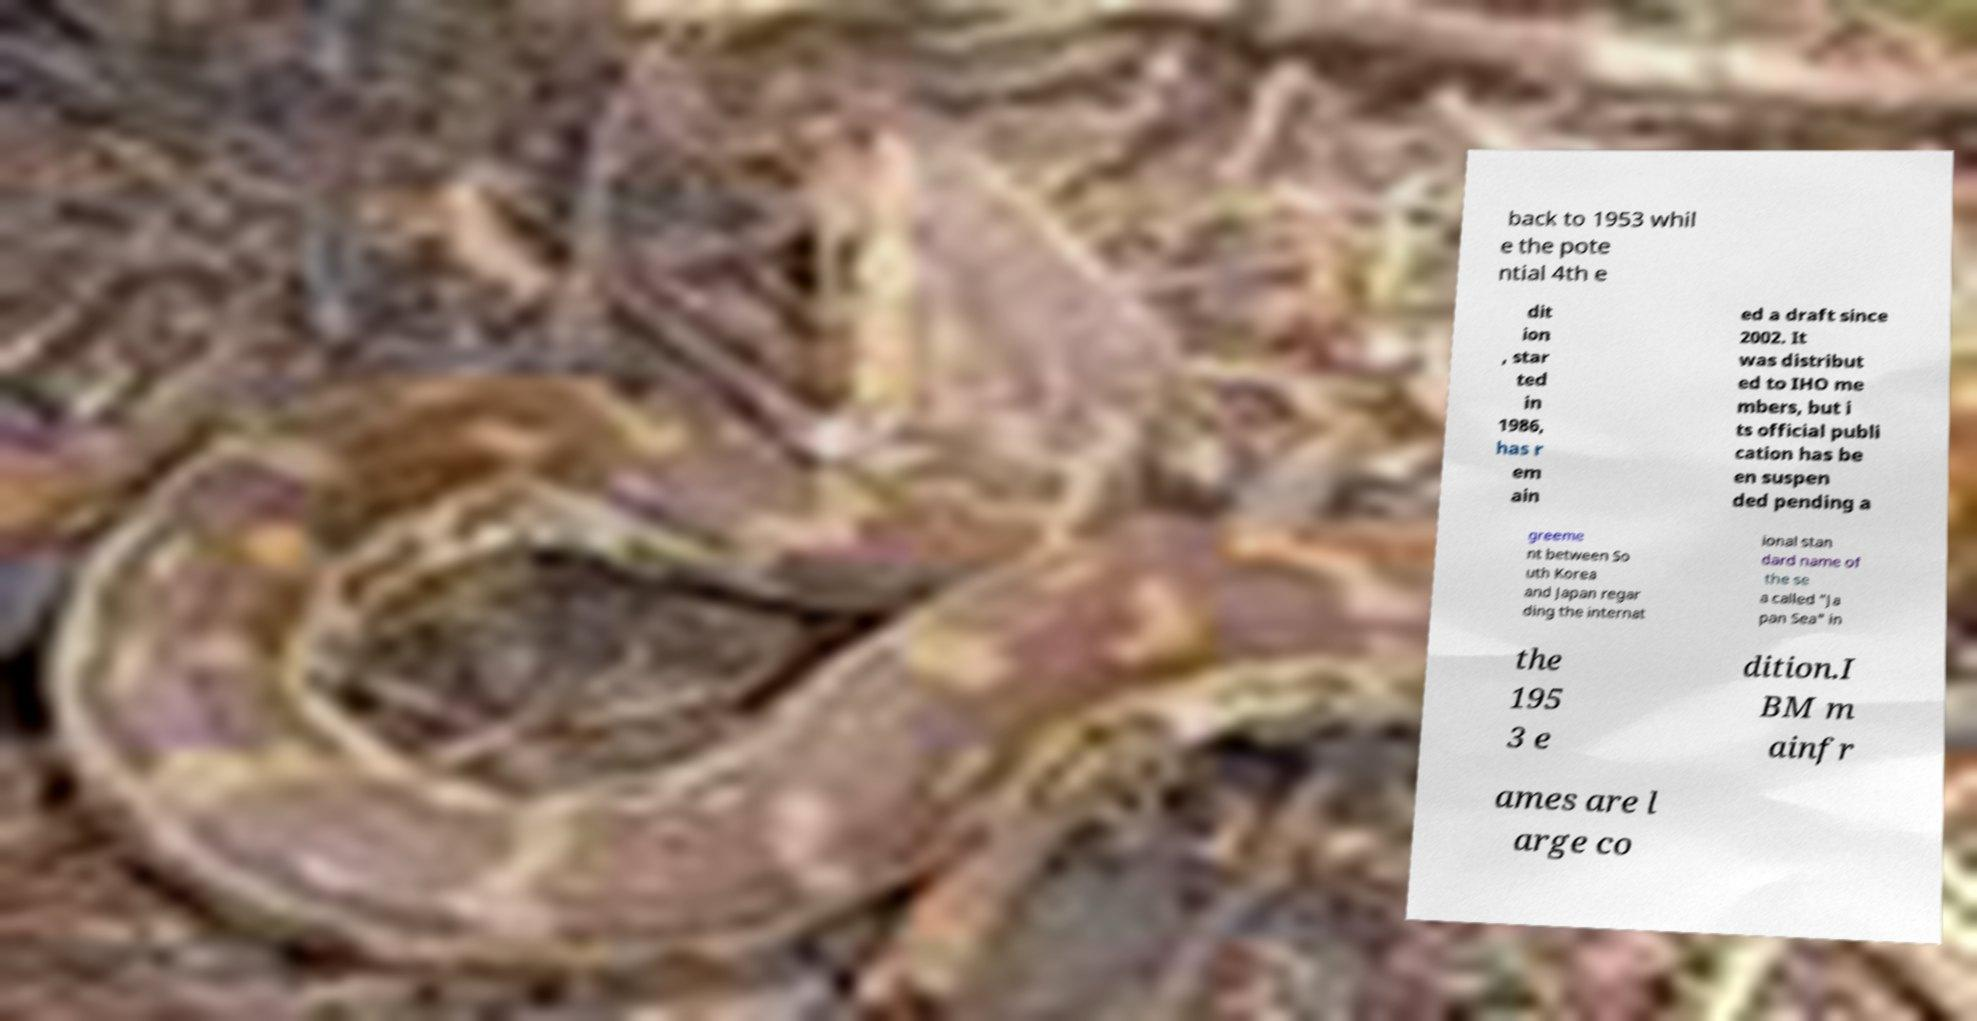There's text embedded in this image that I need extracted. Can you transcribe it verbatim? back to 1953 whil e the pote ntial 4th e dit ion , star ted in 1986, has r em ain ed a draft since 2002. It was distribut ed to IHO me mbers, but i ts official publi cation has be en suspen ded pending a greeme nt between So uth Korea and Japan regar ding the internat ional stan dard name of the se a called "Ja pan Sea" in the 195 3 e dition.I BM m ainfr ames are l arge co 